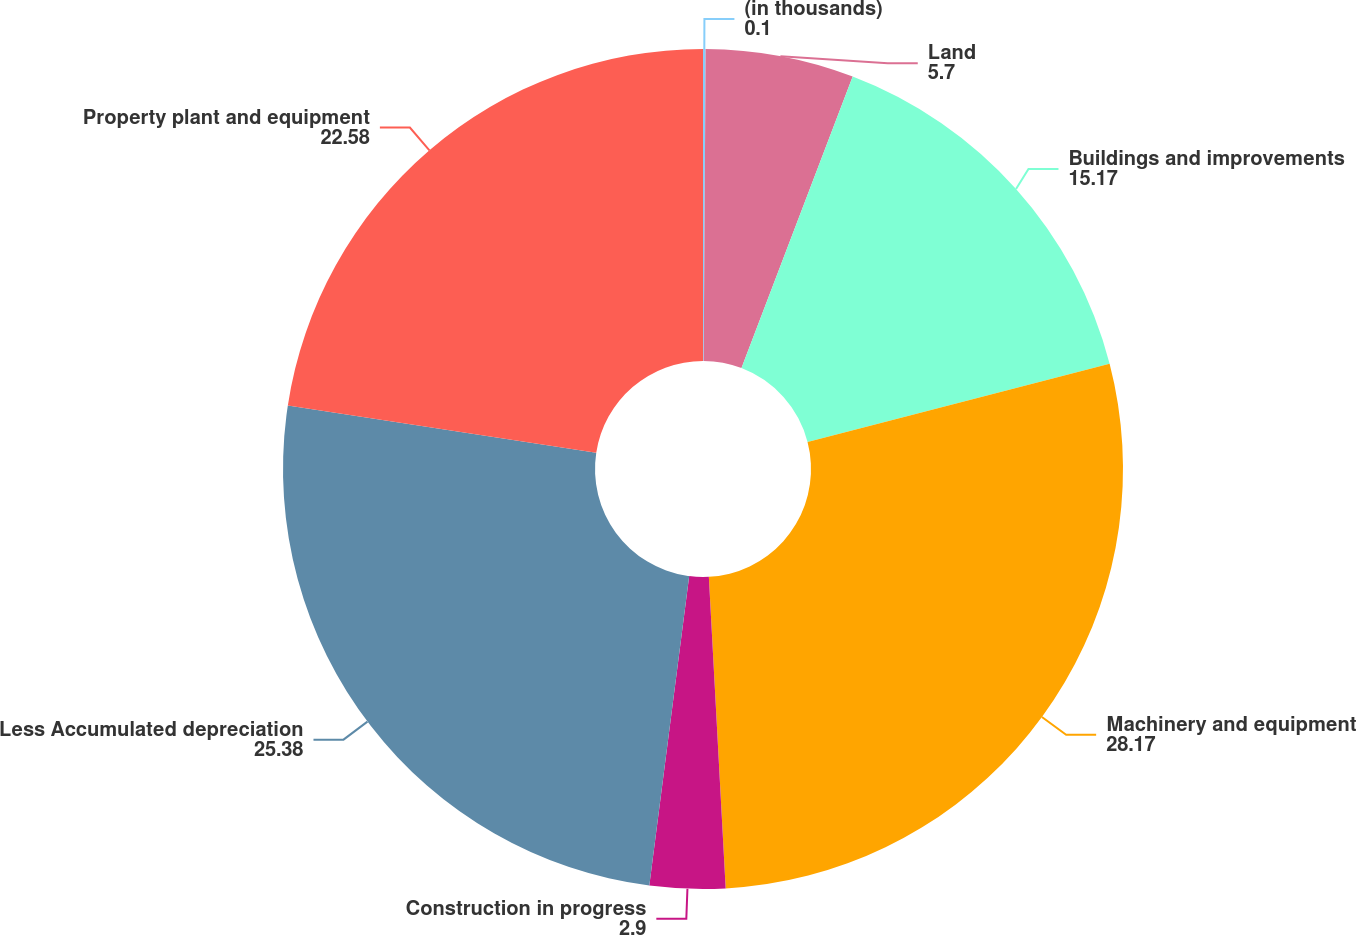<chart> <loc_0><loc_0><loc_500><loc_500><pie_chart><fcel>(in thousands)<fcel>Land<fcel>Buildings and improvements<fcel>Machinery and equipment<fcel>Construction in progress<fcel>Less Accumulated depreciation<fcel>Property plant and equipment<nl><fcel>0.1%<fcel>5.7%<fcel>15.17%<fcel>28.17%<fcel>2.9%<fcel>25.38%<fcel>22.58%<nl></chart> 